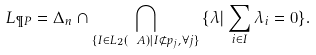<formula> <loc_0><loc_0><loc_500><loc_500>L _ { \P P } = \Delta _ { n } \cap \bigcap _ { \{ I \in \L L _ { 2 } ( \ A ) | I \not \subset p _ { j } , \forall j \} } \, \{ \lambda | \sum _ { i \in I } \lambda _ { i } = 0 \} .</formula> 